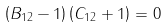Convert formula to latex. <formula><loc_0><loc_0><loc_500><loc_500>\left ( B _ { 1 2 } - { 1 } \right ) \left ( C _ { 1 2 } + { 1 } \right ) = 0</formula> 